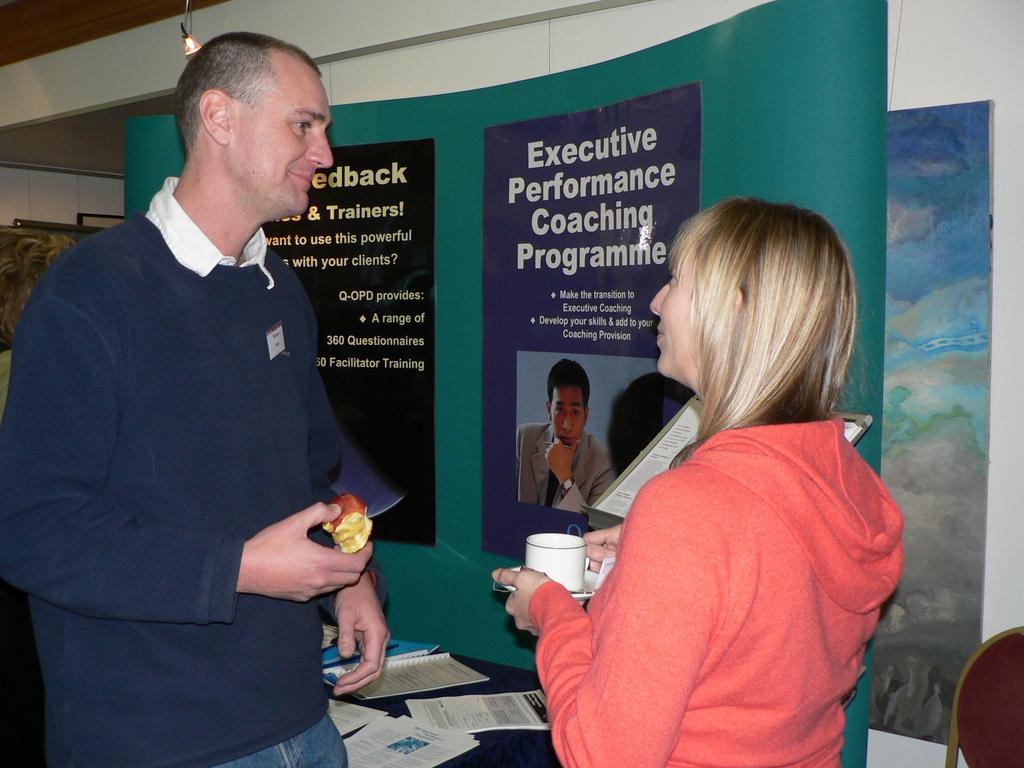In one or two sentences, can you explain what this image depicts? In this picture I can see a man and a woman standing in front and I see that the woman is holding a cup and a saucer and the man is holding an apple. Behind them I can see a table on which there are papers. In the background I can see the wall and I can see the banners on which there is something written and I see the picture of a person. 